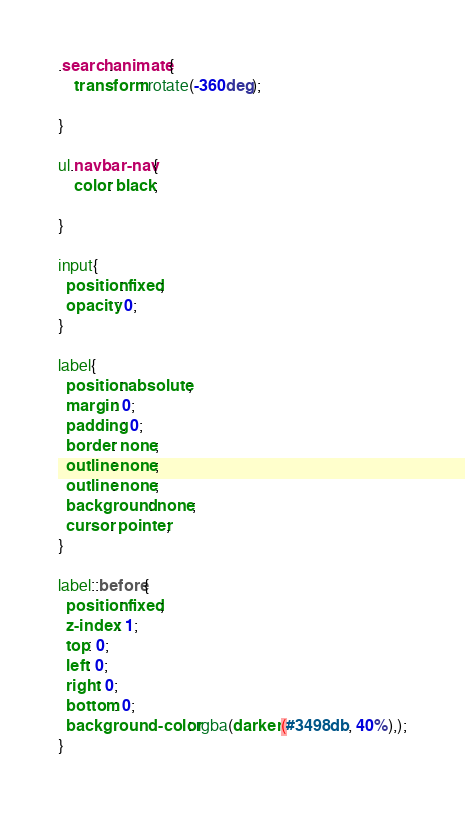Convert code to text. <code><loc_0><loc_0><loc_500><loc_500><_CSS_>.search.animate{
    transform: rotate(-360deg);
    
}

ul.navbar-nav{
    color: black;

}

input{
  position: fixed;
  opacity: 0;
}

label{
  position: absolute;
  margin: 0;
  padding: 0;
  border: none;
  outline: none;
  outline: none;
  background: none;
  cursor: pointer;
}

label::before{
  position: fixed;
  z-index: 1;
  top: 0;
  left: 0;
  right: 0;
  bottom: 0;
  background-color: rgba(darken(#3498db, 40%),);
}</code> 